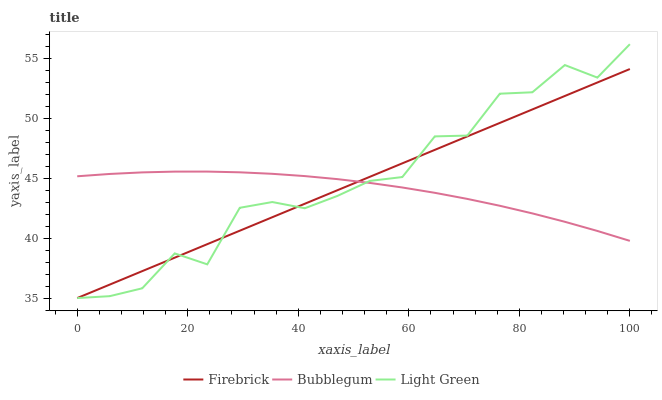Does Bubblegum have the minimum area under the curve?
Answer yes or no. Yes. Does Light Green have the maximum area under the curve?
Answer yes or no. Yes. Does Light Green have the minimum area under the curve?
Answer yes or no. No. Does Bubblegum have the maximum area under the curve?
Answer yes or no. No. Is Firebrick the smoothest?
Answer yes or no. Yes. Is Light Green the roughest?
Answer yes or no. Yes. Is Bubblegum the smoothest?
Answer yes or no. No. Is Bubblegum the roughest?
Answer yes or no. No. Does Bubblegum have the lowest value?
Answer yes or no. No. Does Light Green have the highest value?
Answer yes or no. Yes. Does Bubblegum have the highest value?
Answer yes or no. No. Does Light Green intersect Firebrick?
Answer yes or no. Yes. Is Light Green less than Firebrick?
Answer yes or no. No. Is Light Green greater than Firebrick?
Answer yes or no. No. 